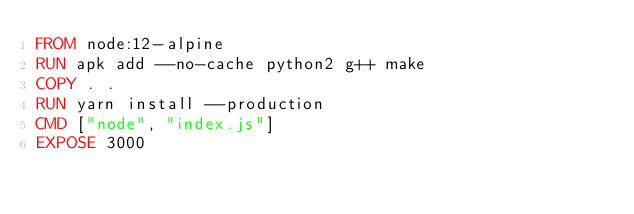Convert code to text. <code><loc_0><loc_0><loc_500><loc_500><_Dockerfile_>FROM node:12-alpine
RUN apk add --no-cache python2 g++ make
COPY . .
RUN yarn install --production
CMD ["node", "index.js"]
EXPOSE 3000
</code> 